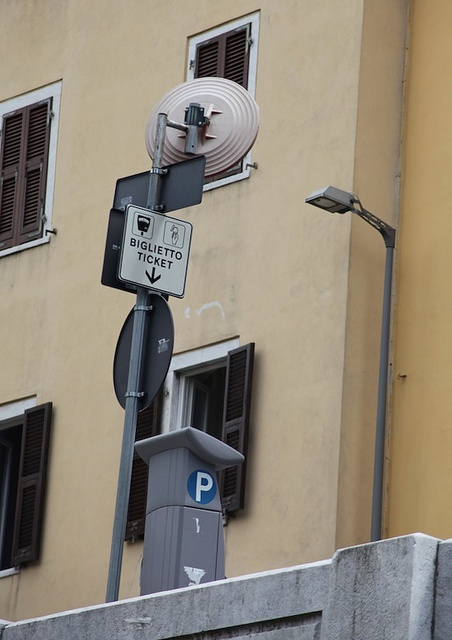Describe the objects in this image and their specific colors. I can see a parking meter in darkgray, gray, black, and navy tones in this image. 